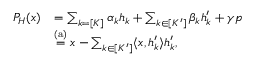<formula> <loc_0><loc_0><loc_500><loc_500>\begin{array} { r l } { P _ { H } ( x ) } & { = \sum _ { k = [ K ] } \alpha _ { k } h _ { k } + \sum _ { k \in [ K ^ { \prime } ] } \beta _ { k } h _ { k } ^ { \prime } + \gamma p } \\ & { \stackrel { ( a ) } { = } x - \sum _ { k \in [ K ^ { \prime } ] } \langle x , h _ { k } ^ { \prime } \rangle h _ { k } ^ { \prime } , } \end{array}</formula> 